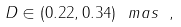<formula> <loc_0><loc_0><loc_500><loc_500>D \in ( 0 . 2 2 , 0 . 3 4 ) \ m a s \ ,</formula> 